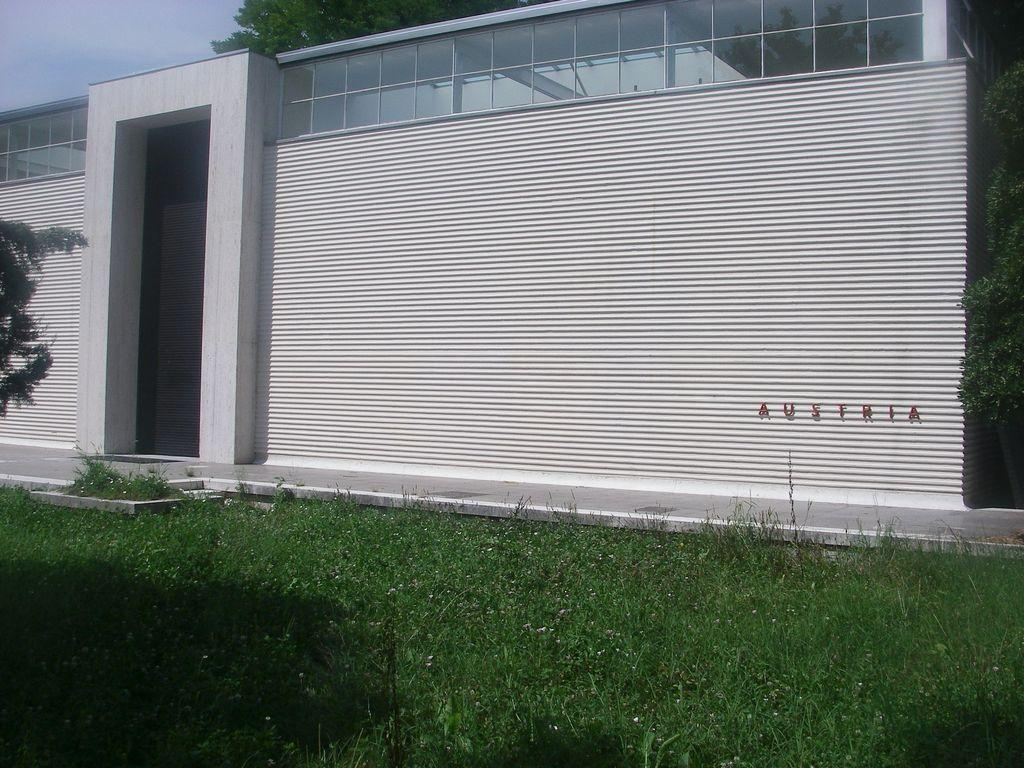What type of structure is visible in the image? There is a house in the image. What type of vegetation is present in the image? There is grass in the image. Where is the name board located in the image? The name board is on the wall on the right side of the image. What can be seen in the background of the image? There are trees and the sky visible in the background of the image. Can you see a bee stitching a voyage in the image? There is no bee, stitching, or voyage present in the image. 